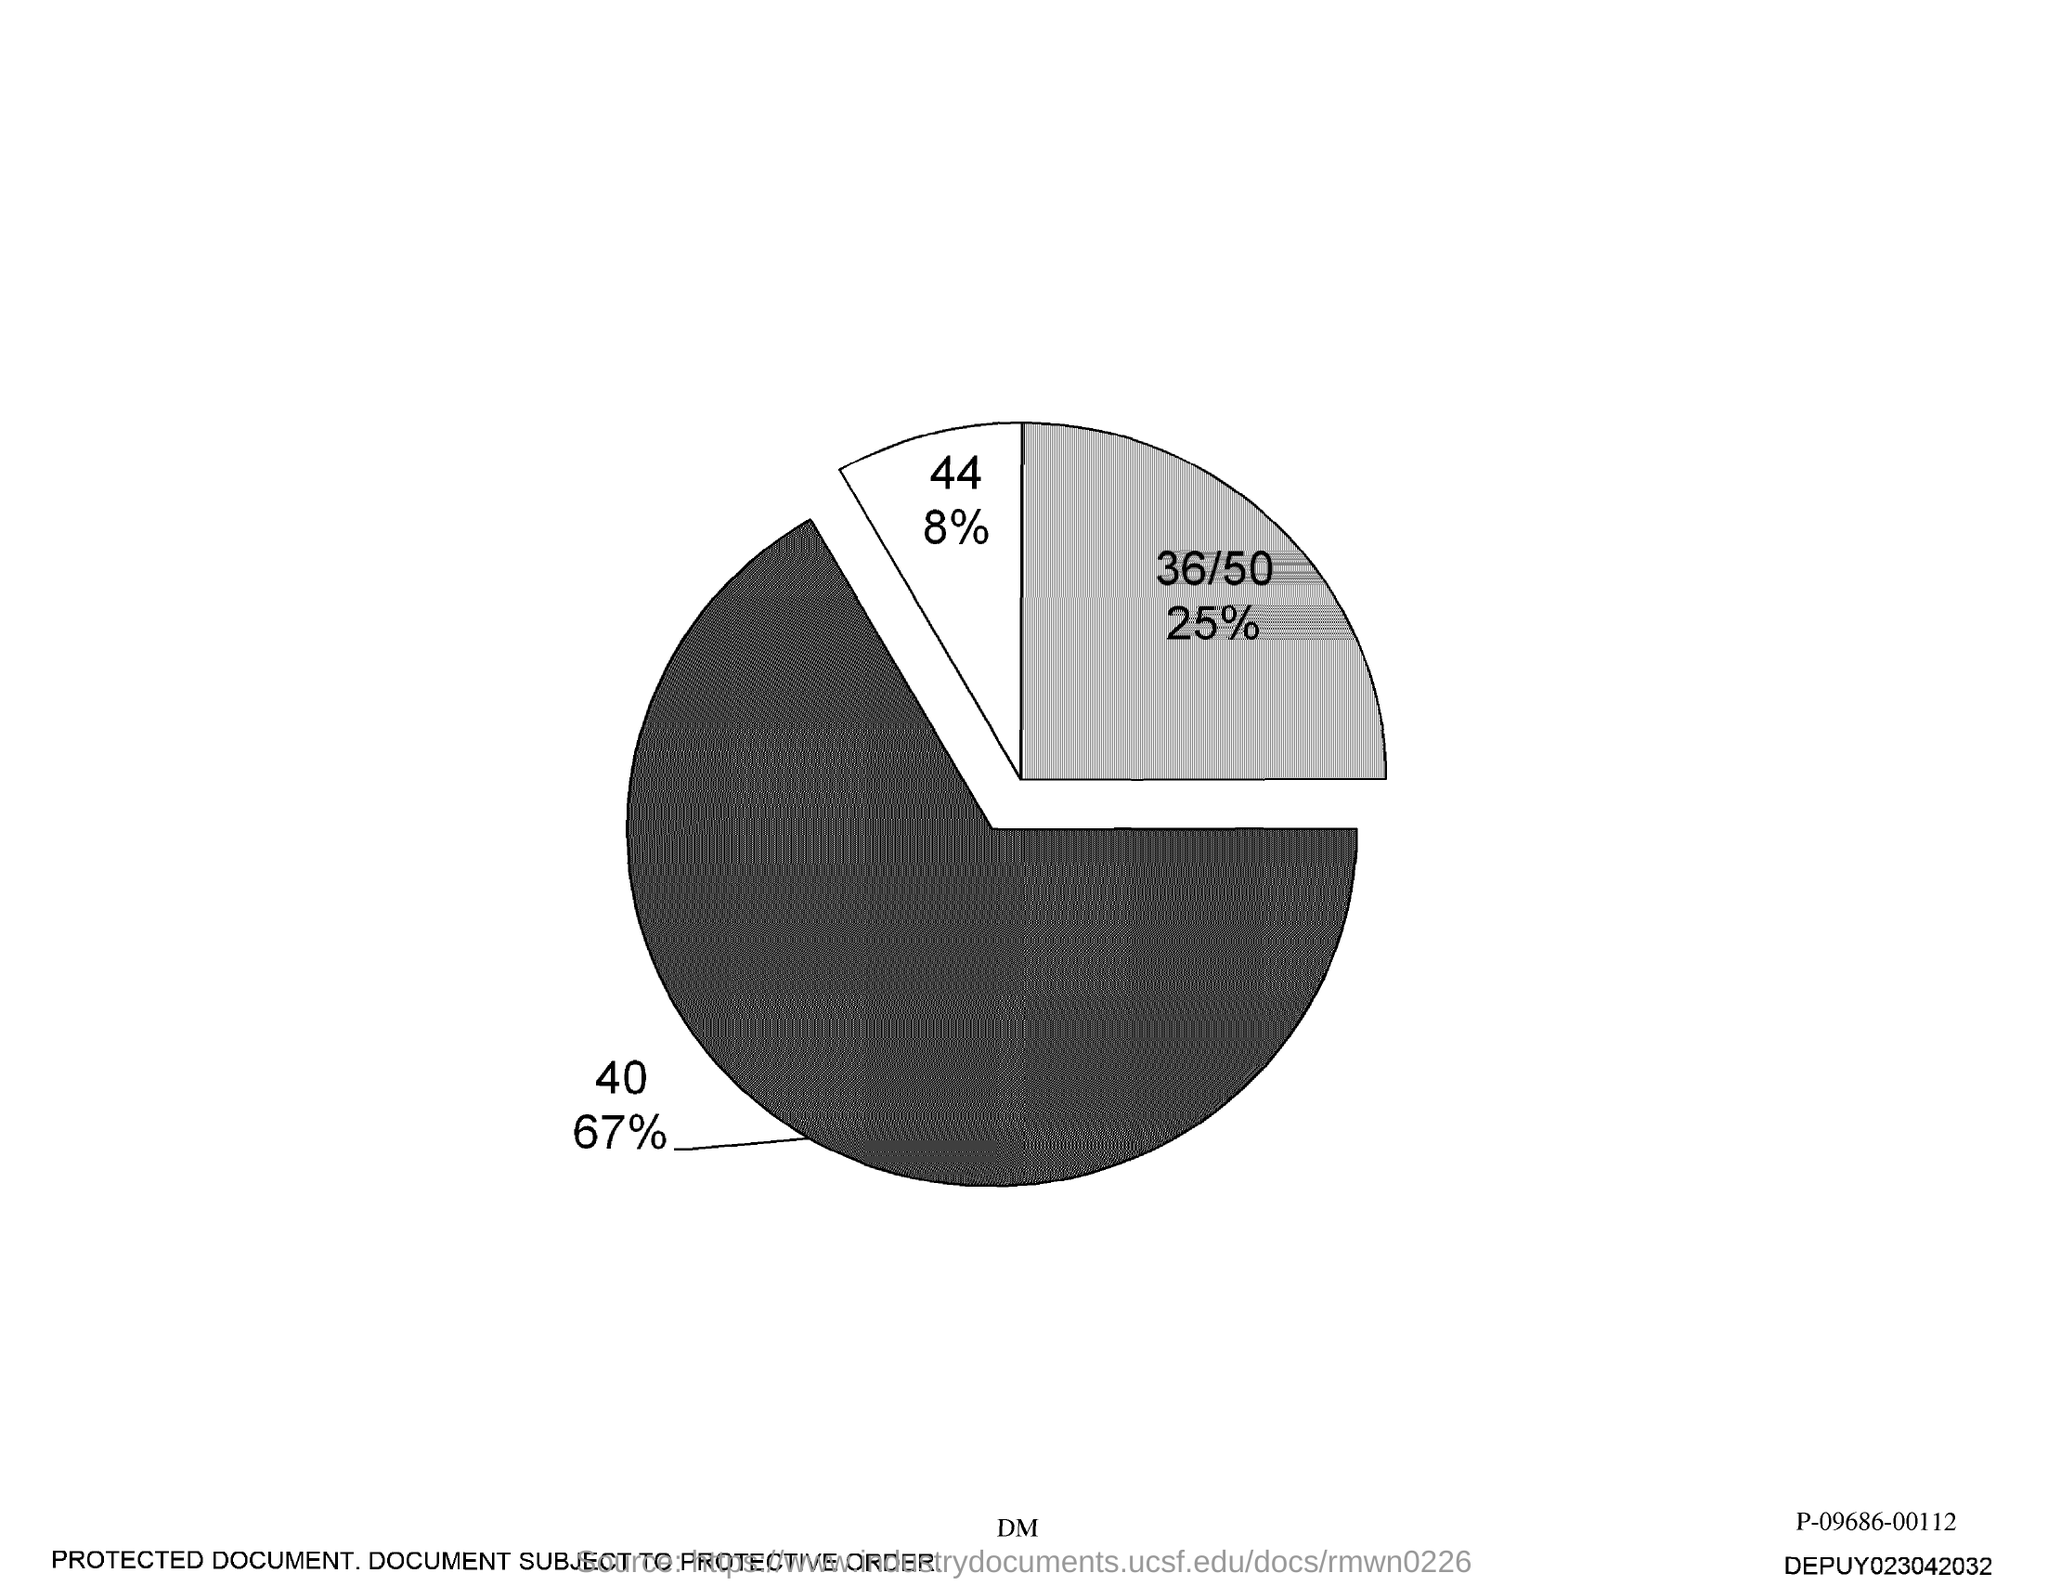What is the highest percentage?
Offer a terse response. 67%. What is the second-highest percentage?
Provide a succinct answer. 25. What is the lowest percentage?
Your response must be concise. 8. Which number is associated with 8%?
Keep it short and to the point. 44. 